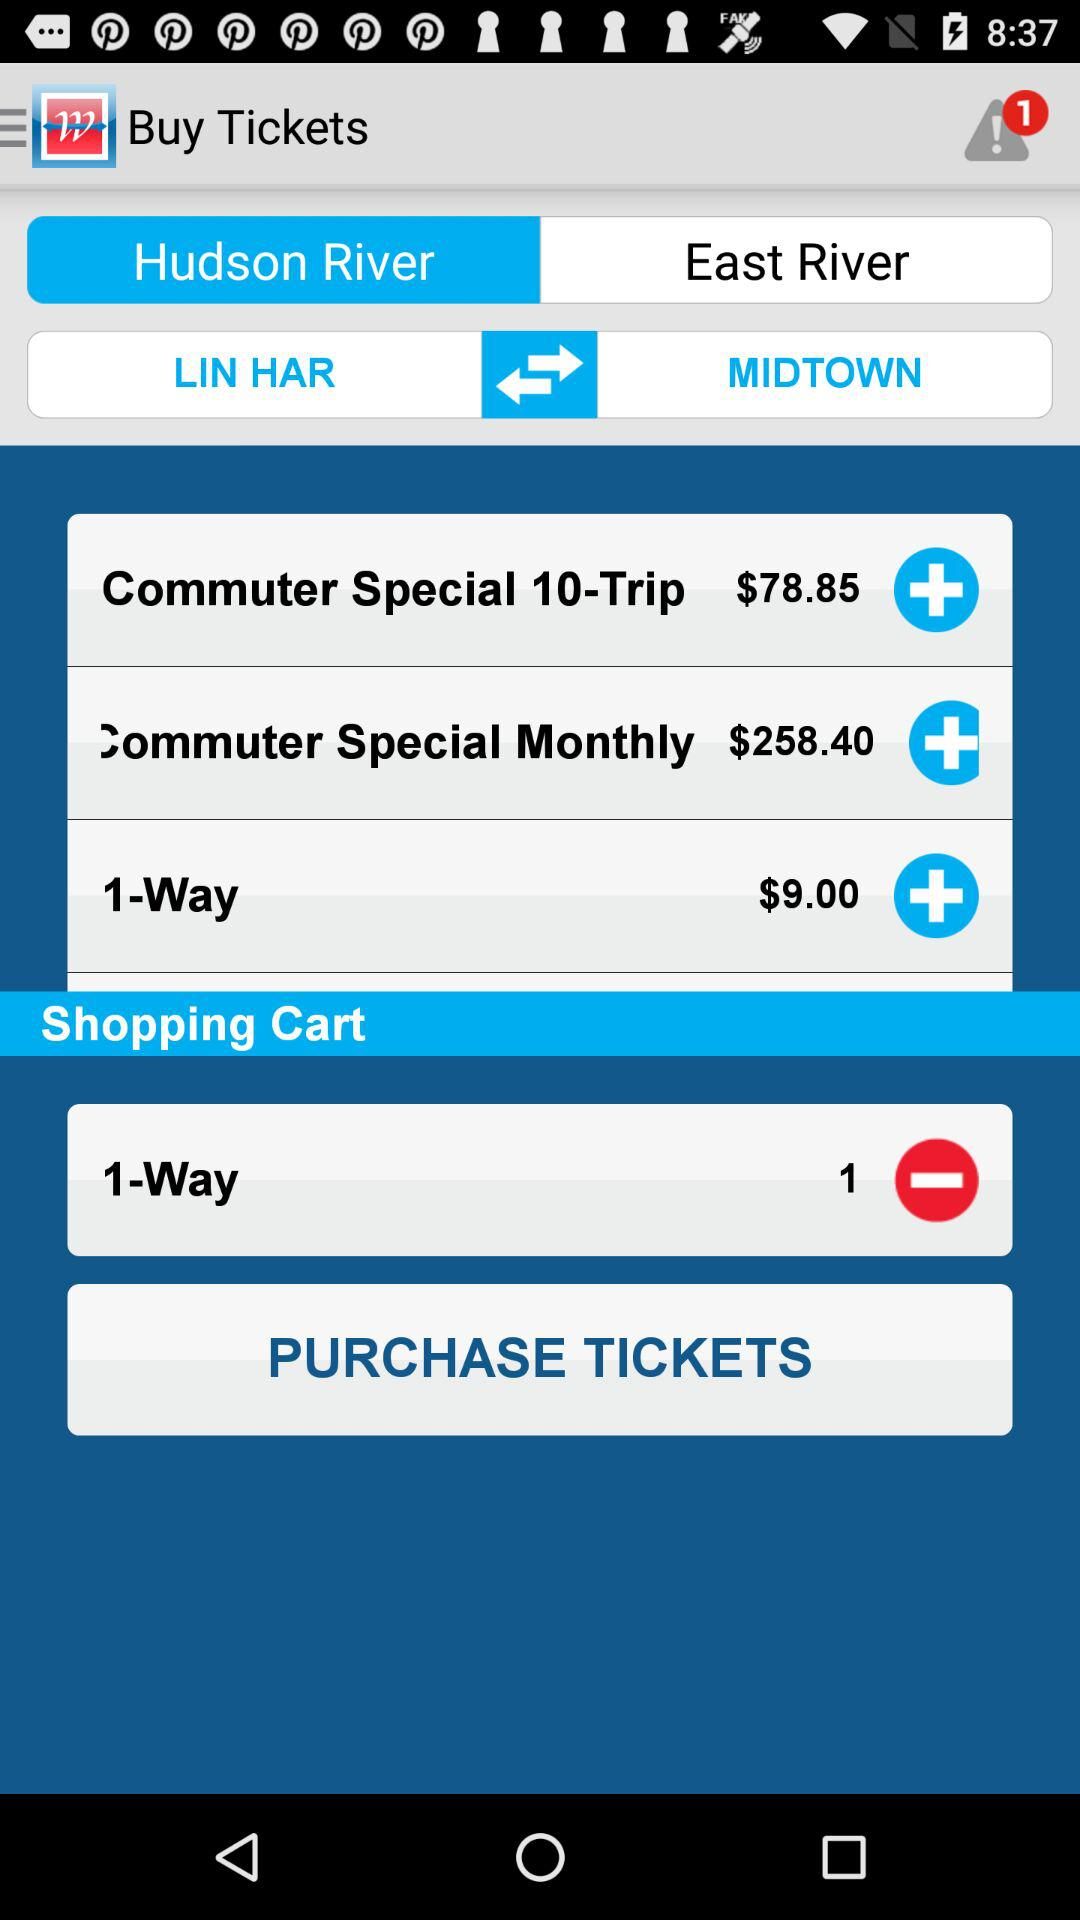What is the currency of fare? The used currency is dollars. 